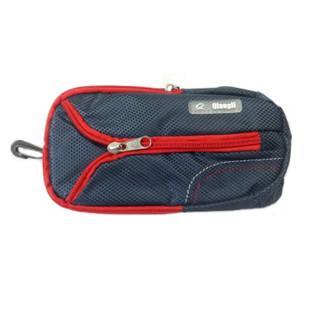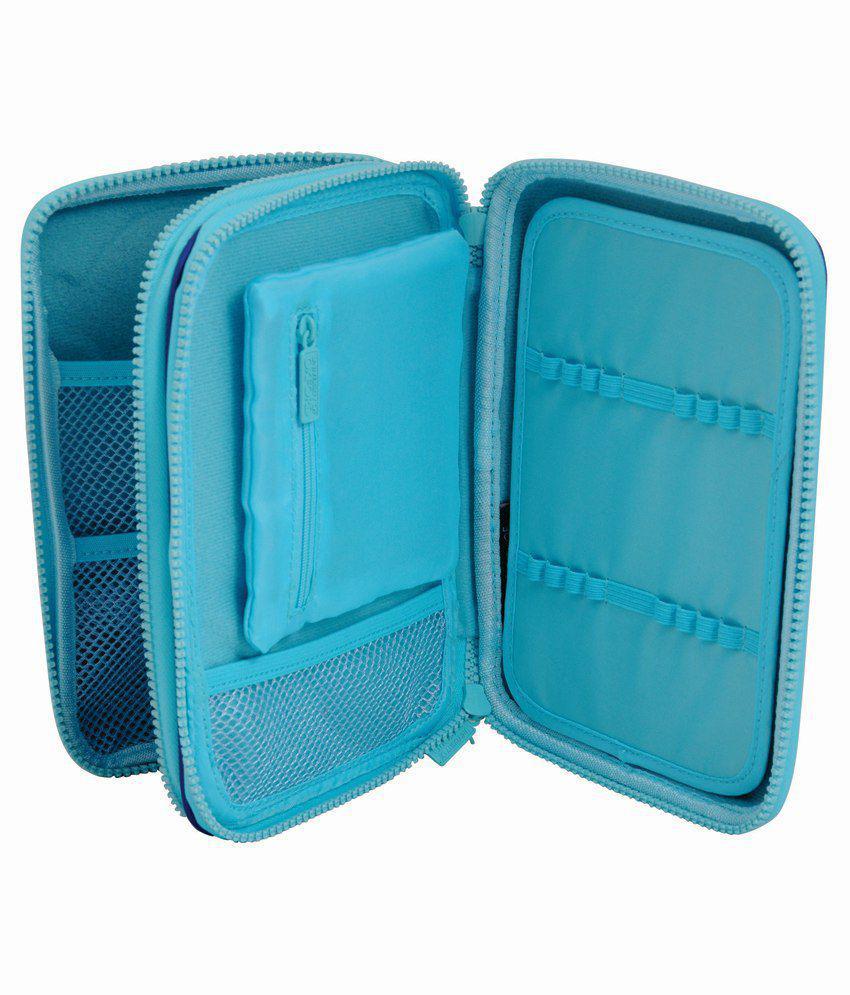The first image is the image on the left, the second image is the image on the right. Given the left and right images, does the statement "Atleast one item is light blue" hold true? Answer yes or no. Yes. The first image is the image on the left, the second image is the image on the right. Evaluate the accuracy of this statement regarding the images: "One case is zipped shut and displayed horizontally, while the other is a blue multi-zippered compartment case displayed upright, open, and fanned out.". Is it true? Answer yes or no. Yes. 